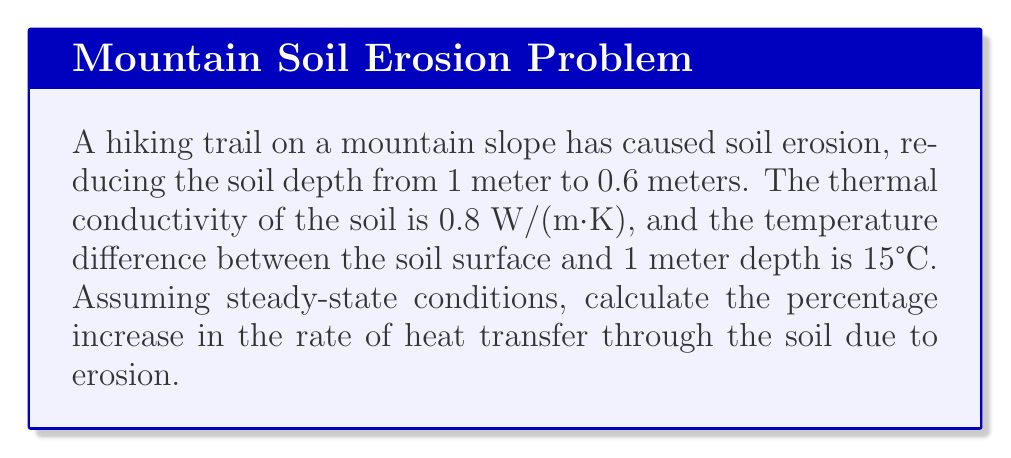Can you solve this math problem? To solve this problem, we'll use Fourier's law of heat conduction and compare the heat transfer rates before and after erosion.

1. Fourier's law of heat conduction:
   $$q = -k \frac{dT}{dx}$$
   where $q$ is the heat flux (W/m²), $k$ is thermal conductivity (W/(m·K)), and $\frac{dT}{dx}$ is the temperature gradient (K/m).

2. Before erosion:
   Soil depth $L_1 = 1$ m
   Temperature difference $\Delta T = 15°C = 15$ K
   Thermal conductivity $k = 0.8$ W/(m·K)

   Heat flux: $q_1 = k \frac{\Delta T}{L_1} = 0.8 \cdot \frac{15}{1} = 12$ W/m²

3. After erosion:
   Soil depth $L_2 = 0.6$ m
   Temperature difference and thermal conductivity remain the same.

   Heat flux: $q_2 = k \frac{\Delta T}{L_2} = 0.8 \cdot \frac{15}{0.6} = 20$ W/m²

4. Calculate the percentage increase:
   Percentage increase = $\frac{q_2 - q_1}{q_1} \cdot 100\%$
   $= \frac{20 - 12}{12} \cdot 100\% = \frac{8}{12} \cdot 100\% = 66.67\%$

Therefore, the rate of heat transfer through the soil has increased by approximately 66.67% due to erosion.
Answer: 66.67% 